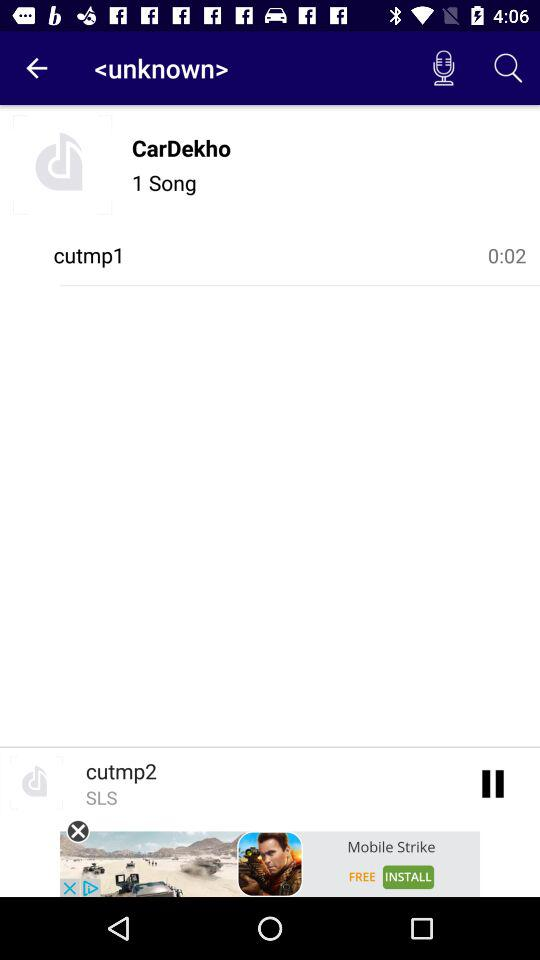What is the name of song?
When the provided information is insufficient, respond with <no answer>. <no answer> 